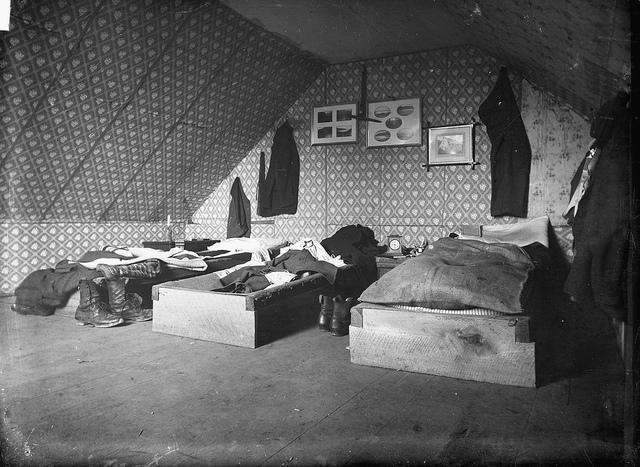How many pairs of boots are visible?
Give a very brief answer. 2. How many beds can you see?
Give a very brief answer. 3. How many people are holding wine glasses?
Give a very brief answer. 0. 